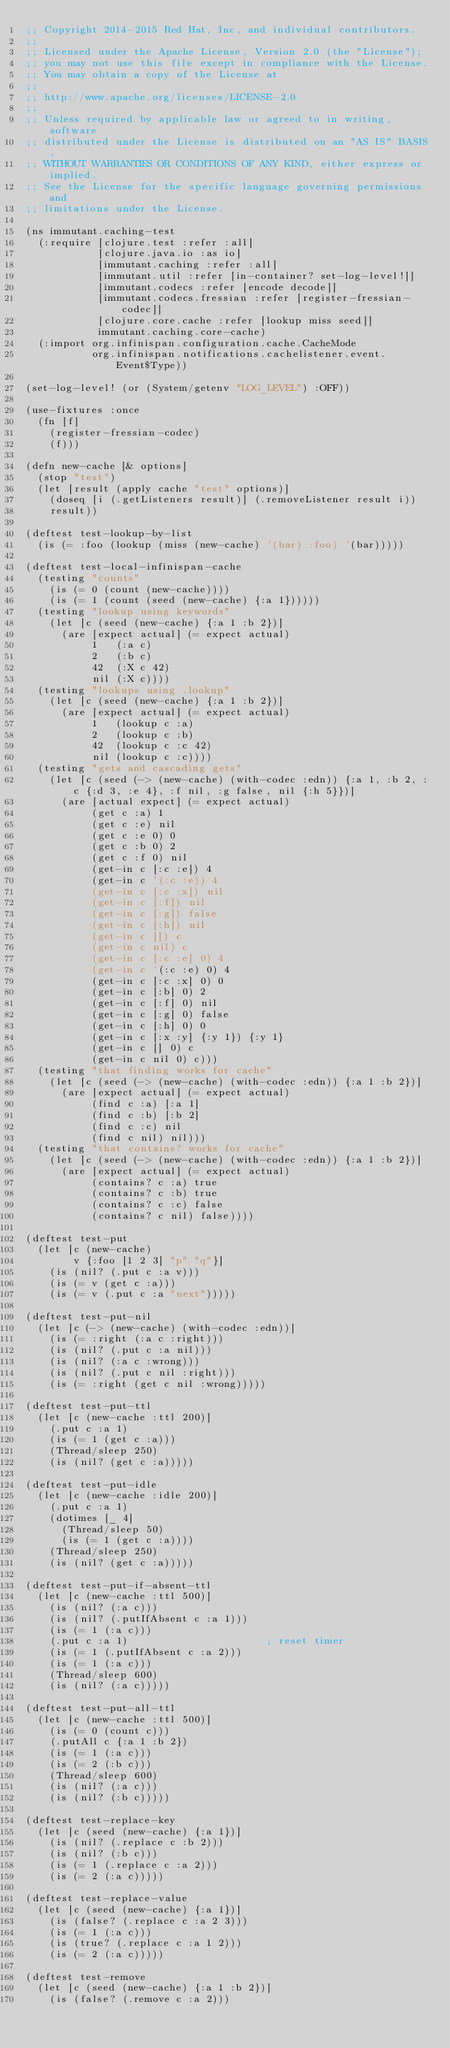<code> <loc_0><loc_0><loc_500><loc_500><_Clojure_>;; Copyright 2014-2015 Red Hat, Inc, and individual contributors.
;;
;; Licensed under the Apache License, Version 2.0 (the "License");
;; you may not use this file except in compliance with the License.
;; You may obtain a copy of the License at
;;
;; http://www.apache.org/licenses/LICENSE-2.0
;;
;; Unless required by applicable law or agreed to in writing, software
;; distributed under the License is distributed on an "AS IS" BASIS,
;; WITHOUT WARRANTIES OR CONDITIONS OF ANY KIND, either express or implied.
;; See the License for the specific language governing permissions and
;; limitations under the License.

(ns immutant.caching-test
  (:require [clojure.test :refer :all]
            [clojure.java.io :as io]
            [immutant.caching :refer :all]
            [immutant.util :refer [in-container? set-log-level!]]
            [immutant.codecs :refer [encode decode]]
            [immutant.codecs.fressian :refer [register-fressian-codec]]
            [clojure.core.cache :refer [lookup miss seed]]
            immutant.caching.core-cache)
  (:import org.infinispan.configuration.cache.CacheMode
           org.infinispan.notifications.cachelistener.event.Event$Type))

(set-log-level! (or (System/getenv "LOG_LEVEL") :OFF))

(use-fixtures :once
  (fn [f]
    (register-fressian-codec)
    (f)))

(defn new-cache [& options]
  (stop "test")
  (let [result (apply cache "test" options)]
    (doseq [i (.getListeners result)] (.removeListener result i))
    result))

(deftest test-lookup-by-list
  (is (= :foo (lookup (miss (new-cache) '(bar) :foo) '(bar)))))

(deftest test-local-infinispan-cache
  (testing "counts"
    (is (= 0 (count (new-cache))))
    (is (= 1 (count (seed (new-cache) {:a 1})))))
  (testing "lookup using keywords"
    (let [c (seed (new-cache) {:a 1 :b 2})]
      (are [expect actual] (= expect actual)
           1   (:a c)
           2   (:b c)
           42  (:X c 42)
           nil (:X c))))
  (testing "lookups using .lookup"
    (let [c (seed (new-cache) {:a 1 :b 2})]
      (are [expect actual] (= expect actual)
           1   (lookup c :a)
           2   (lookup c :b)
           42  (lookup c :c 42)
           nil (lookup c :c))))
  (testing "gets and cascading gets"
    (let [c (seed (-> (new-cache) (with-codec :edn)) {:a 1, :b 2, :c {:d 3, :e 4}, :f nil, :g false, nil {:h 5}})]
      (are [actual expect] (= expect actual)
           (get c :a) 1
           (get c :e) nil
           (get c :e 0) 0
           (get c :b 0) 2
           (get c :f 0) nil
           (get-in c [:c :e]) 4
           (get-in c '(:c :e)) 4
           (get-in c [:c :x]) nil
           (get-in c [:f]) nil
           (get-in c [:g]) false
           (get-in c [:h]) nil
           (get-in c []) c
           (get-in c nil) c
           (get-in c [:c :e] 0) 4
           (get-in c '(:c :e) 0) 4
           (get-in c [:c :x] 0) 0
           (get-in c [:b] 0) 2
           (get-in c [:f] 0) nil
           (get-in c [:g] 0) false
           (get-in c [:h] 0) 0
           (get-in c [:x :y] {:y 1}) {:y 1}
           (get-in c [] 0) c
           (get-in c nil 0) c)))
  (testing "that finding works for cache"
    (let [c (seed (-> (new-cache) (with-codec :edn)) {:a 1 :b 2})]
      (are [expect actual] (= expect actual)
           (find c :a) [:a 1]
           (find c :b) [:b 2]
           (find c :c) nil
           (find c nil) nil)))
  (testing "that contains? works for cache"
    (let [c (seed (-> (new-cache) (with-codec :edn)) {:a 1 :b 2})]
      (are [expect actual] (= expect actual)
           (contains? c :a) true
           (contains? c :b) true
           (contains? c :c) false
           (contains? c nil) false))))

(deftest test-put
  (let [c (new-cache)
        v {:foo [1 2 3] "p" "q"}]
    (is (nil? (.put c :a v)))
    (is (= v (get c :a)))
    (is (= v (.put c :a "next")))))

(deftest test-put-nil
  (let [c (-> (new-cache) (with-codec :edn))]
    (is (= :right (:a c :right)))
    (is (nil? (.put c :a nil)))
    (is (nil? (:a c :wrong)))
    (is (nil? (.put c nil :right)))
    (is (= :right (get c nil :wrong)))))

(deftest test-put-ttl
  (let [c (new-cache :ttl 200)]
    (.put c :a 1)
    (is (= 1 (get c :a)))
    (Thread/sleep 250)
    (is (nil? (get c :a)))))

(deftest test-put-idle
  (let [c (new-cache :idle 200)]
    (.put c :a 1)
    (dotimes [_ 4]
      (Thread/sleep 50)
      (is (= 1 (get c :a))))
    (Thread/sleep 250)
    (is (nil? (get c :a)))))

(deftest test-put-if-absent-ttl
  (let [c (new-cache :ttl 500)]
    (is (nil? (:a c)))
    (is (nil? (.putIfAbsent c :a 1)))
    (is (= 1 (:a c)))
    (.put c :a 1)                       ; reset timer
    (is (= 1 (.putIfAbsent c :a 2)))
    (is (= 1 (:a c)))
    (Thread/sleep 600)
    (is (nil? (:a c)))))

(deftest test-put-all-ttl
  (let [c (new-cache :ttl 500)]
    (is (= 0 (count c)))
    (.putAll c {:a 1 :b 2})
    (is (= 1 (:a c)))
    (is (= 2 (:b c)))
    (Thread/sleep 600)
    (is (nil? (:a c)))
    (is (nil? (:b c)))))

(deftest test-replace-key
  (let [c (seed (new-cache) {:a 1})]
    (is (nil? (.replace c :b 2)))
    (is (nil? (:b c)))
    (is (= 1 (.replace c :a 2)))
    (is (= 2 (:a c)))))

(deftest test-replace-value
  (let [c (seed (new-cache) {:a 1})]
    (is (false? (.replace c :a 2 3)))
    (is (= 1 (:a c)))
    (is (true? (.replace c :a 1 2)))
    (is (= 2 (:a c)))))

(deftest test-remove
  (let [c (seed (new-cache) {:a 1 :b 2})]
    (is (false? (.remove c :a 2)))</code> 